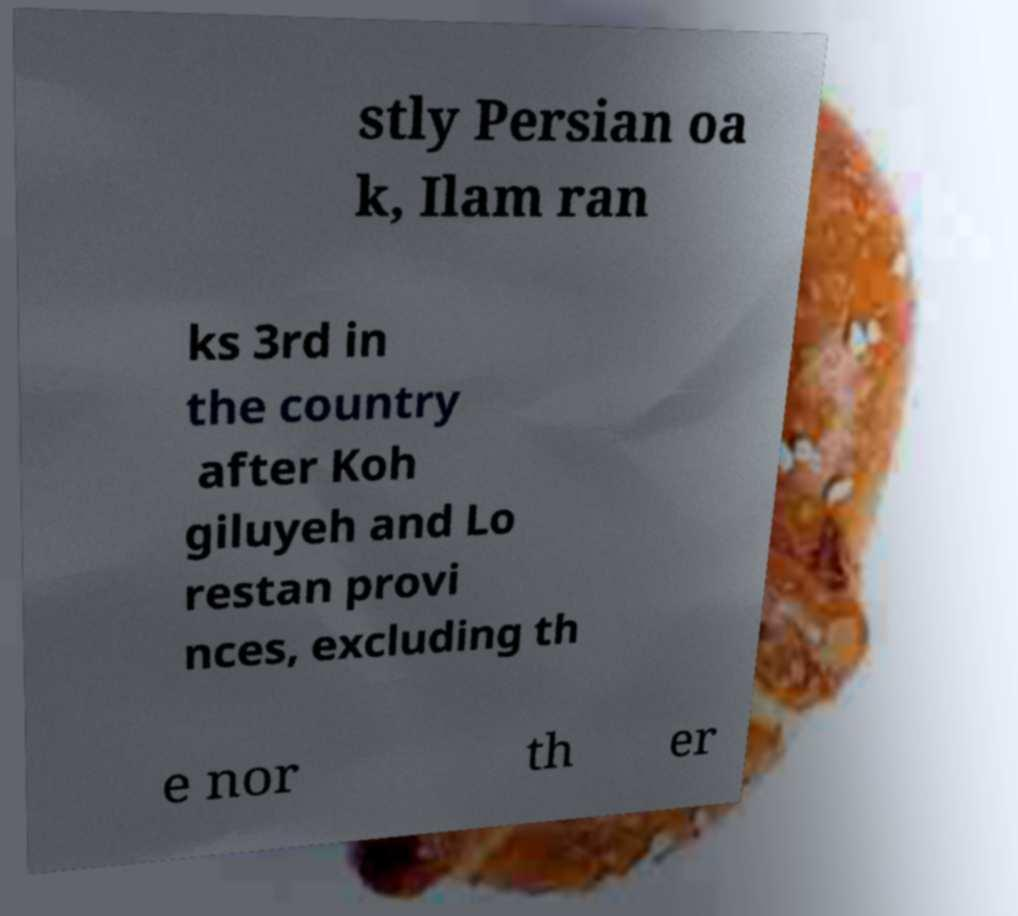What messages or text are displayed in this image? I need them in a readable, typed format. stly Persian oa k, Ilam ran ks 3rd in the country after Koh giluyeh and Lo restan provi nces, excluding th e nor th er 